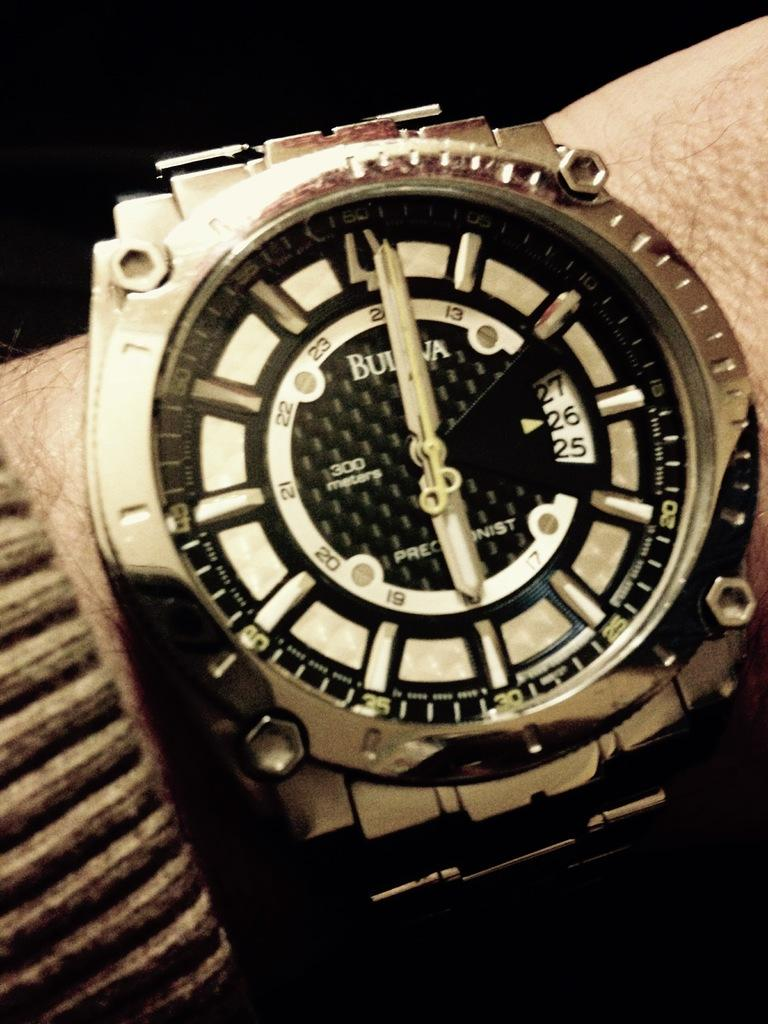<image>
Render a clear and concise summary of the photo. A CHARCOAL/SILVER BULOVA WATCH ON A MANS WRIST WITH THE DATE 26 